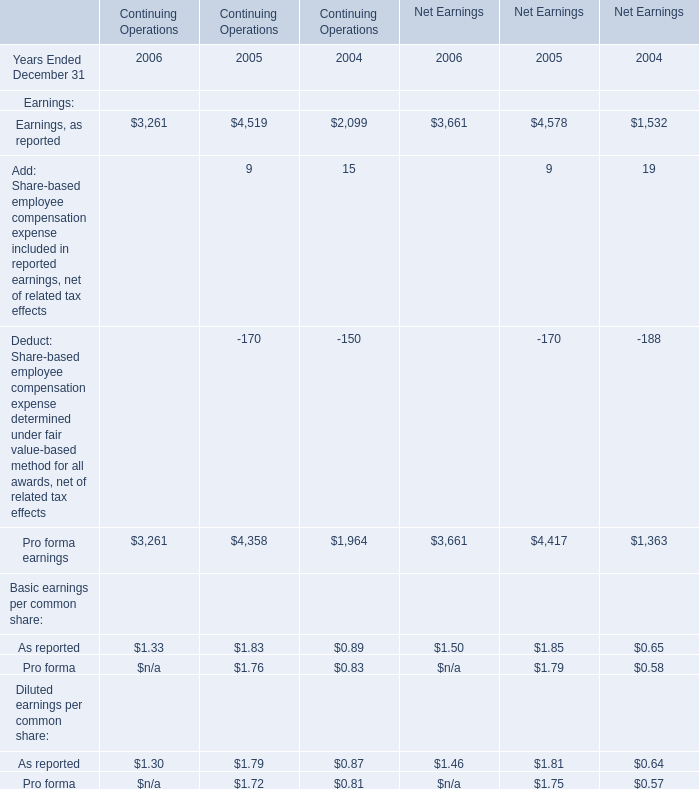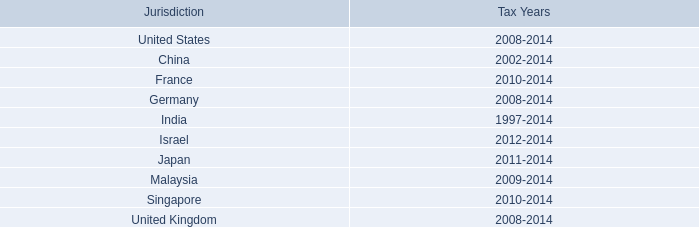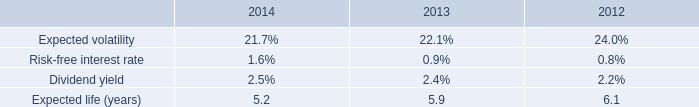What is the growing rate of Earnings, as reported for Continuing Operations in the year Ended December 31 with the most Pro forma earnings for Continuing Operations? 
Computations: ((4519 - 2099) / 2099)
Answer: 1.15293. 